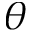<formula> <loc_0><loc_0><loc_500><loc_500>\theta</formula> 